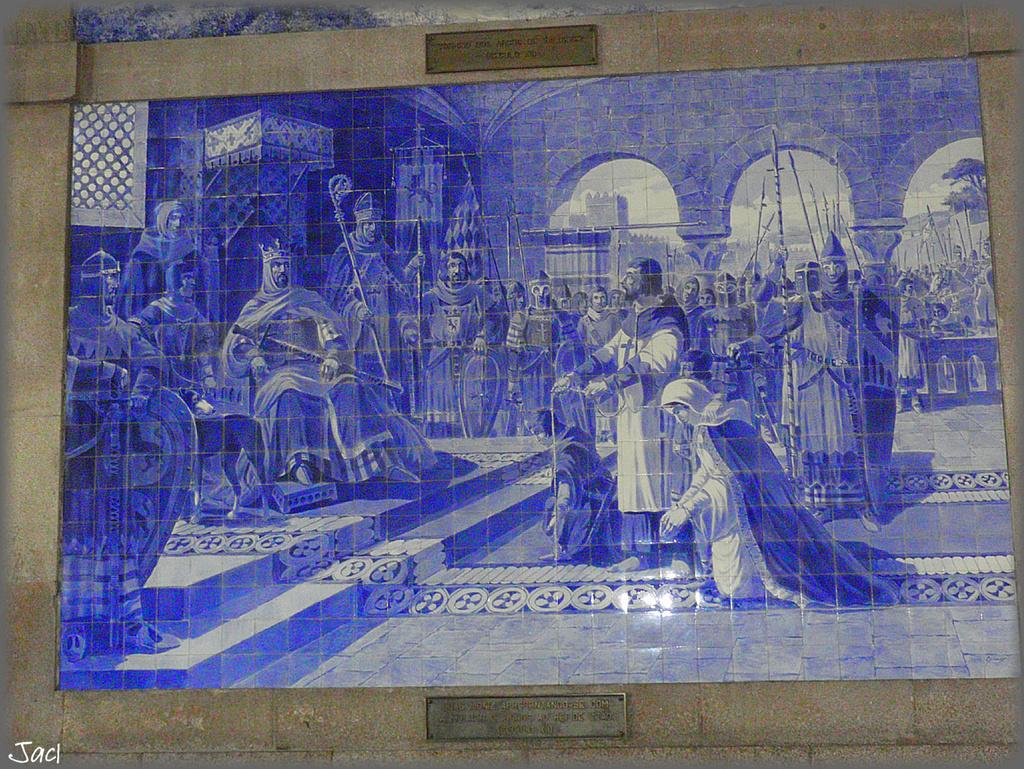What is on the wall in the image? There is a poster and name boards on the wall in the image. Can you describe the poster? Unfortunately, the details of the poster cannot be determined from the provided facts. What is written on the name boards? The information on the name boards cannot be determined from the provided facts. Where is the text located in the image? The text is visible in the bottom left of the image. How many sisters are playing in the cellar in the image? There is no mention of a cellar or sisters in the image. The image only contains a poster, name boards, and text on the wall. 